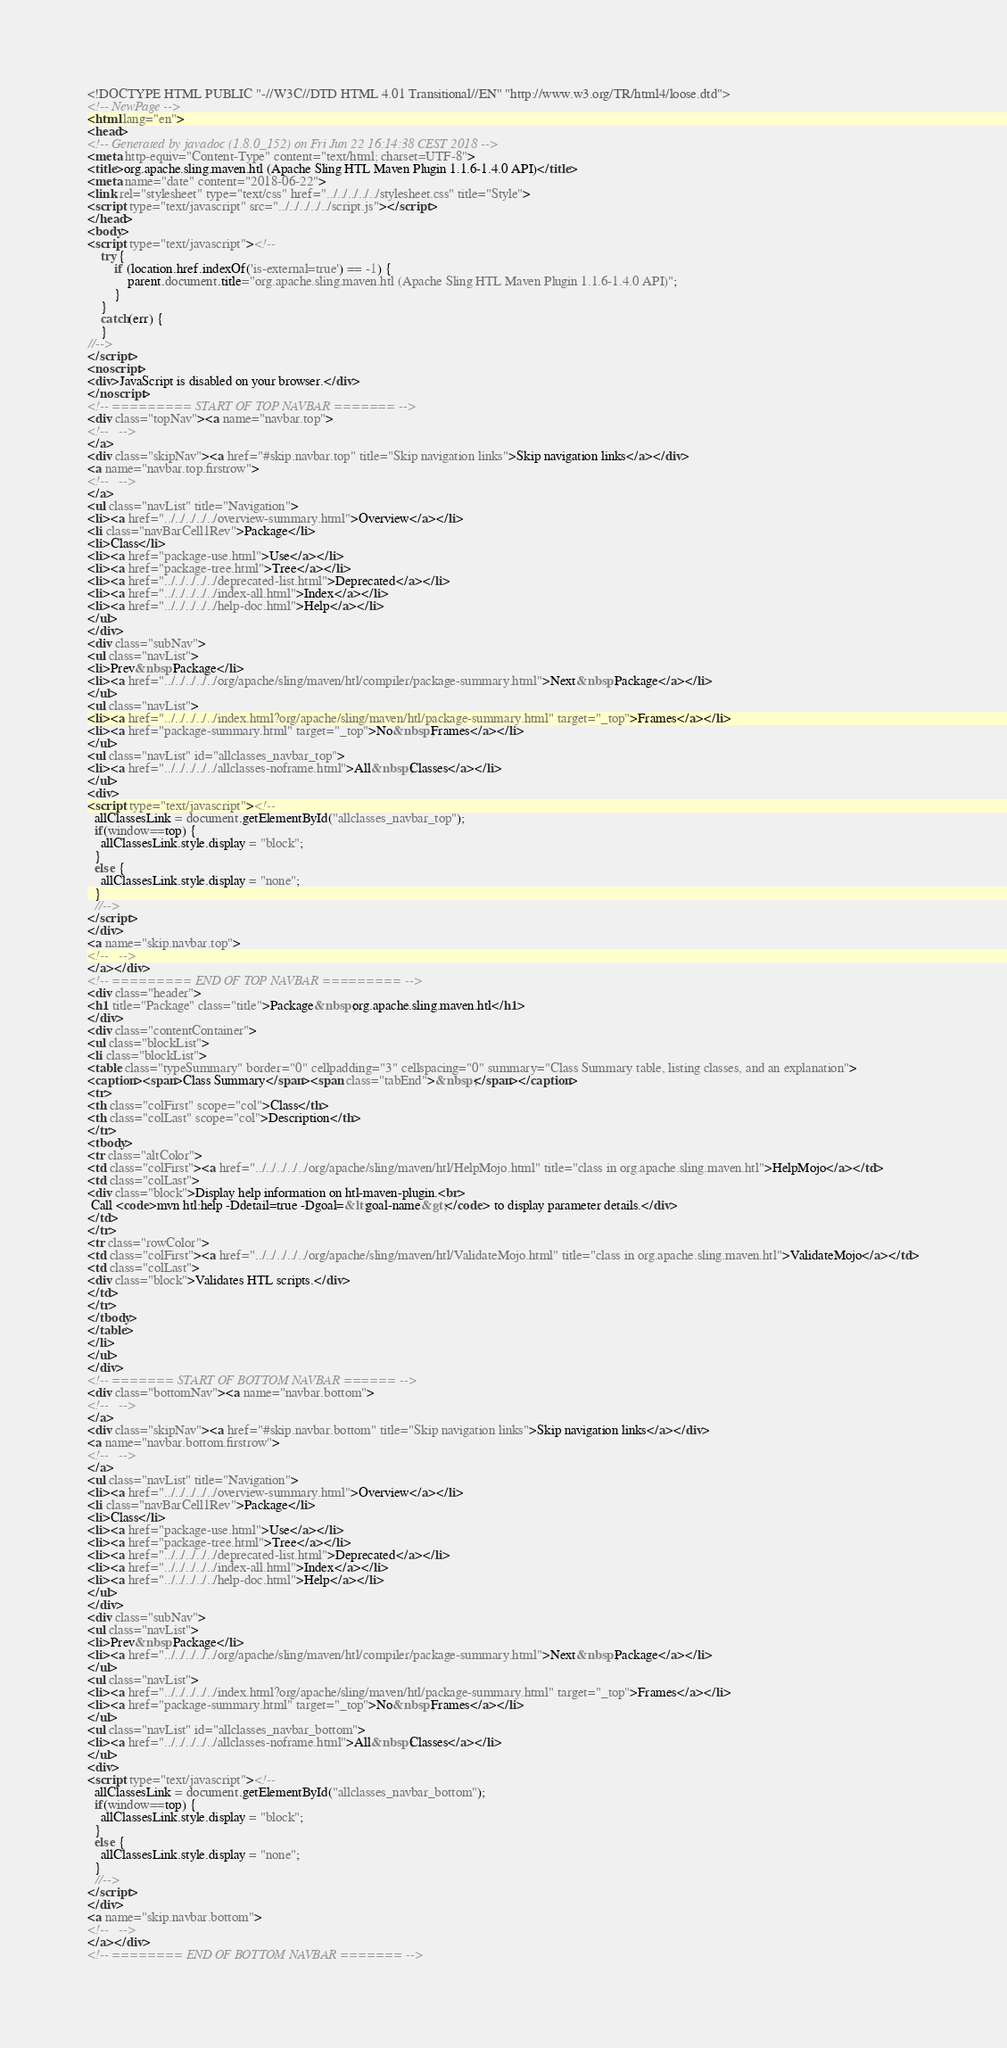<code> <loc_0><loc_0><loc_500><loc_500><_HTML_><!DOCTYPE HTML PUBLIC "-//W3C//DTD HTML 4.01 Transitional//EN" "http://www.w3.org/TR/html4/loose.dtd">
<!-- NewPage -->
<html lang="en">
<head>
<!-- Generated by javadoc (1.8.0_152) on Fri Jun 22 16:14:38 CEST 2018 -->
<meta http-equiv="Content-Type" content="text/html; charset=UTF-8">
<title>org.apache.sling.maven.htl (Apache Sling HTL Maven Plugin 1.1.6-1.4.0 API)</title>
<meta name="date" content="2018-06-22">
<link rel="stylesheet" type="text/css" href="../../../../../stylesheet.css" title="Style">
<script type="text/javascript" src="../../../../../script.js"></script>
</head>
<body>
<script type="text/javascript"><!--
    try {
        if (location.href.indexOf('is-external=true') == -1) {
            parent.document.title="org.apache.sling.maven.htl (Apache Sling HTL Maven Plugin 1.1.6-1.4.0 API)";
        }
    }
    catch(err) {
    }
//-->
</script>
<noscript>
<div>JavaScript is disabled on your browser.</div>
</noscript>
<!-- ========= START OF TOP NAVBAR ======= -->
<div class="topNav"><a name="navbar.top">
<!--   -->
</a>
<div class="skipNav"><a href="#skip.navbar.top" title="Skip navigation links">Skip navigation links</a></div>
<a name="navbar.top.firstrow">
<!--   -->
</a>
<ul class="navList" title="Navigation">
<li><a href="../../../../../overview-summary.html">Overview</a></li>
<li class="navBarCell1Rev">Package</li>
<li>Class</li>
<li><a href="package-use.html">Use</a></li>
<li><a href="package-tree.html">Tree</a></li>
<li><a href="../../../../../deprecated-list.html">Deprecated</a></li>
<li><a href="../../../../../index-all.html">Index</a></li>
<li><a href="../../../../../help-doc.html">Help</a></li>
</ul>
</div>
<div class="subNav">
<ul class="navList">
<li>Prev&nbsp;Package</li>
<li><a href="../../../../../org/apache/sling/maven/htl/compiler/package-summary.html">Next&nbsp;Package</a></li>
</ul>
<ul class="navList">
<li><a href="../../../../../index.html?org/apache/sling/maven/htl/package-summary.html" target="_top">Frames</a></li>
<li><a href="package-summary.html" target="_top">No&nbsp;Frames</a></li>
</ul>
<ul class="navList" id="allclasses_navbar_top">
<li><a href="../../../../../allclasses-noframe.html">All&nbsp;Classes</a></li>
</ul>
<div>
<script type="text/javascript"><!--
  allClassesLink = document.getElementById("allclasses_navbar_top");
  if(window==top) {
    allClassesLink.style.display = "block";
  }
  else {
    allClassesLink.style.display = "none";
  }
  //-->
</script>
</div>
<a name="skip.navbar.top">
<!--   -->
</a></div>
<!-- ========= END OF TOP NAVBAR ========= -->
<div class="header">
<h1 title="Package" class="title">Package&nbsp;org.apache.sling.maven.htl</h1>
</div>
<div class="contentContainer">
<ul class="blockList">
<li class="blockList">
<table class="typeSummary" border="0" cellpadding="3" cellspacing="0" summary="Class Summary table, listing classes, and an explanation">
<caption><span>Class Summary</span><span class="tabEnd">&nbsp;</span></caption>
<tr>
<th class="colFirst" scope="col">Class</th>
<th class="colLast" scope="col">Description</th>
</tr>
<tbody>
<tr class="altColor">
<td class="colFirst"><a href="../../../../../org/apache/sling/maven/htl/HelpMojo.html" title="class in org.apache.sling.maven.htl">HelpMojo</a></td>
<td class="colLast">
<div class="block">Display help information on htl-maven-plugin.<br>
 Call <code>mvn htl:help -Ddetail=true -Dgoal=&lt;goal-name&gt;</code> to display parameter details.</div>
</td>
</tr>
<tr class="rowColor">
<td class="colFirst"><a href="../../../../../org/apache/sling/maven/htl/ValidateMojo.html" title="class in org.apache.sling.maven.htl">ValidateMojo</a></td>
<td class="colLast">
<div class="block">Validates HTL scripts.</div>
</td>
</tr>
</tbody>
</table>
</li>
</ul>
</div>
<!-- ======= START OF BOTTOM NAVBAR ====== -->
<div class="bottomNav"><a name="navbar.bottom">
<!--   -->
</a>
<div class="skipNav"><a href="#skip.navbar.bottom" title="Skip navigation links">Skip navigation links</a></div>
<a name="navbar.bottom.firstrow">
<!--   -->
</a>
<ul class="navList" title="Navigation">
<li><a href="../../../../../overview-summary.html">Overview</a></li>
<li class="navBarCell1Rev">Package</li>
<li>Class</li>
<li><a href="package-use.html">Use</a></li>
<li><a href="package-tree.html">Tree</a></li>
<li><a href="../../../../../deprecated-list.html">Deprecated</a></li>
<li><a href="../../../../../index-all.html">Index</a></li>
<li><a href="../../../../../help-doc.html">Help</a></li>
</ul>
</div>
<div class="subNav">
<ul class="navList">
<li>Prev&nbsp;Package</li>
<li><a href="../../../../../org/apache/sling/maven/htl/compiler/package-summary.html">Next&nbsp;Package</a></li>
</ul>
<ul class="navList">
<li><a href="../../../../../index.html?org/apache/sling/maven/htl/package-summary.html" target="_top">Frames</a></li>
<li><a href="package-summary.html" target="_top">No&nbsp;Frames</a></li>
</ul>
<ul class="navList" id="allclasses_navbar_bottom">
<li><a href="../../../../../allclasses-noframe.html">All&nbsp;Classes</a></li>
</ul>
<div>
<script type="text/javascript"><!--
  allClassesLink = document.getElementById("allclasses_navbar_bottom");
  if(window==top) {
    allClassesLink.style.display = "block";
  }
  else {
    allClassesLink.style.display = "none";
  }
  //-->
</script>
</div>
<a name="skip.navbar.bottom">
<!--   -->
</a></div>
<!-- ======== END OF BOTTOM NAVBAR ======= --></code> 